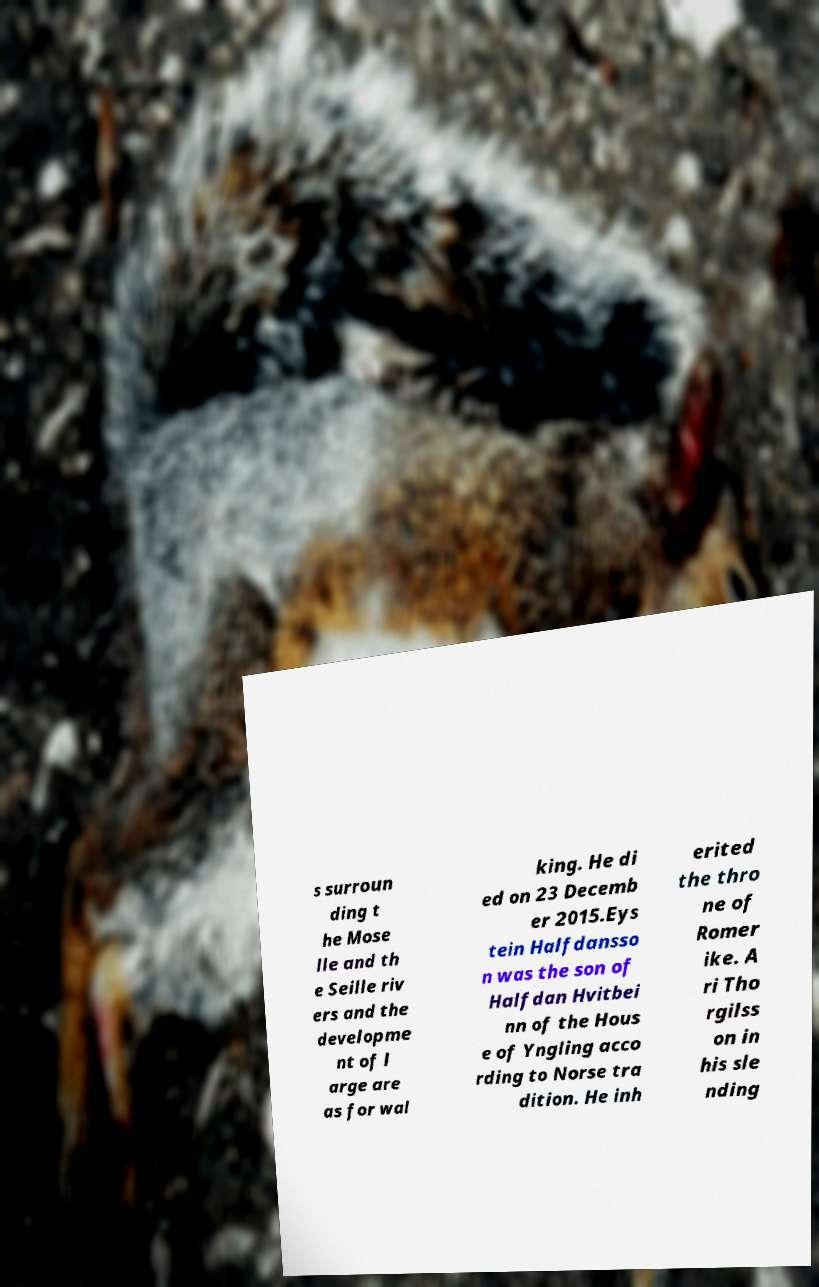Could you assist in decoding the text presented in this image and type it out clearly? s surroun ding t he Mose lle and th e Seille riv ers and the developme nt of l arge are as for wal king. He di ed on 23 Decemb er 2015.Eys tein Halfdansso n was the son of Halfdan Hvitbei nn of the Hous e of Yngling acco rding to Norse tra dition. He inh erited the thro ne of Romer ike. A ri Tho rgilss on in his sle nding 